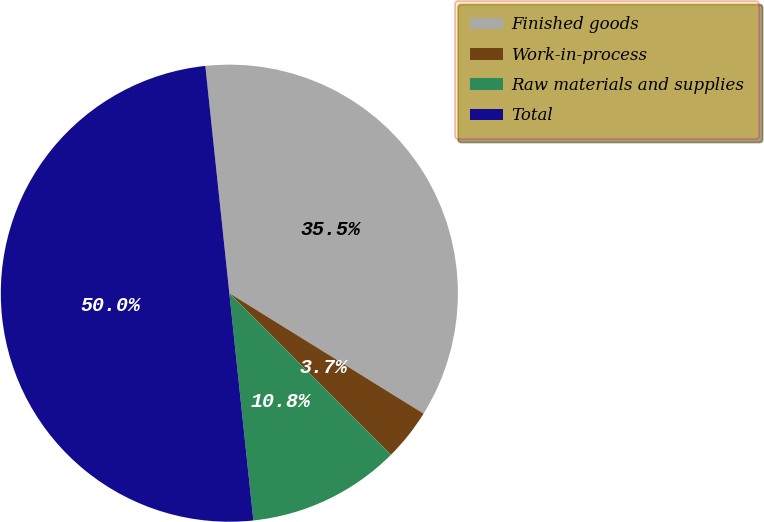Convert chart to OTSL. <chart><loc_0><loc_0><loc_500><loc_500><pie_chart><fcel>Finished goods<fcel>Work-in-process<fcel>Raw materials and supplies<fcel>Total<nl><fcel>35.51%<fcel>3.67%<fcel>10.82%<fcel>50.0%<nl></chart> 